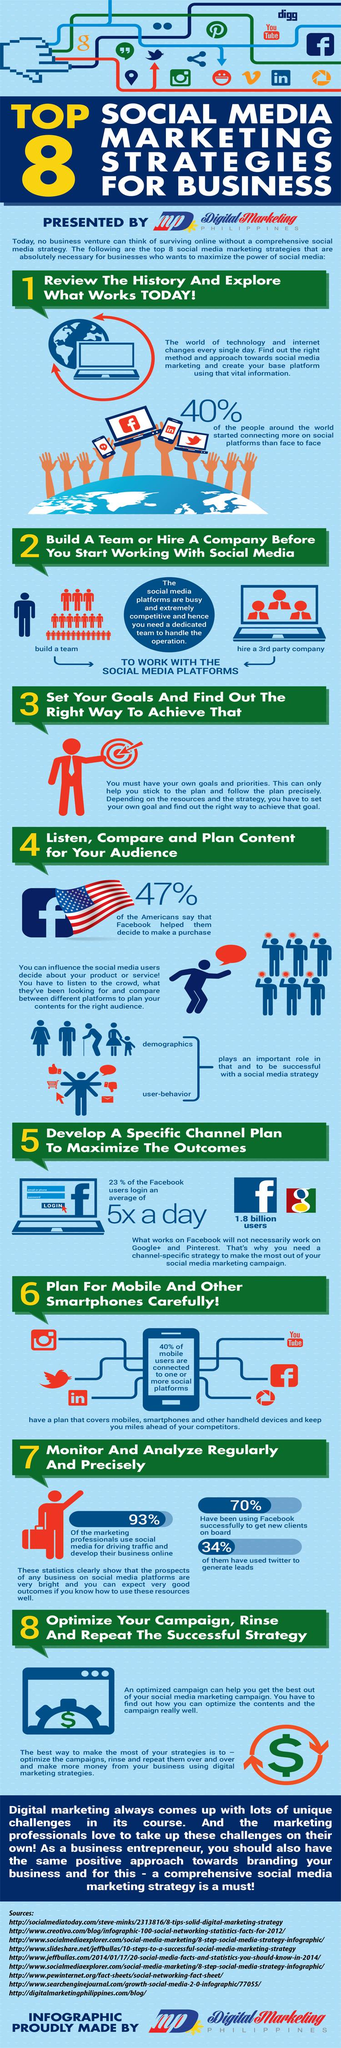List a handful of essential elements in this visual. A significant number of social media apps are used regularly on mobile devices. According to a recent survey, only 7% of marketing professionals do not use social media for marketing. Facebook and Twitter are popular social media platforms that are commonly used to generate prospects online. 